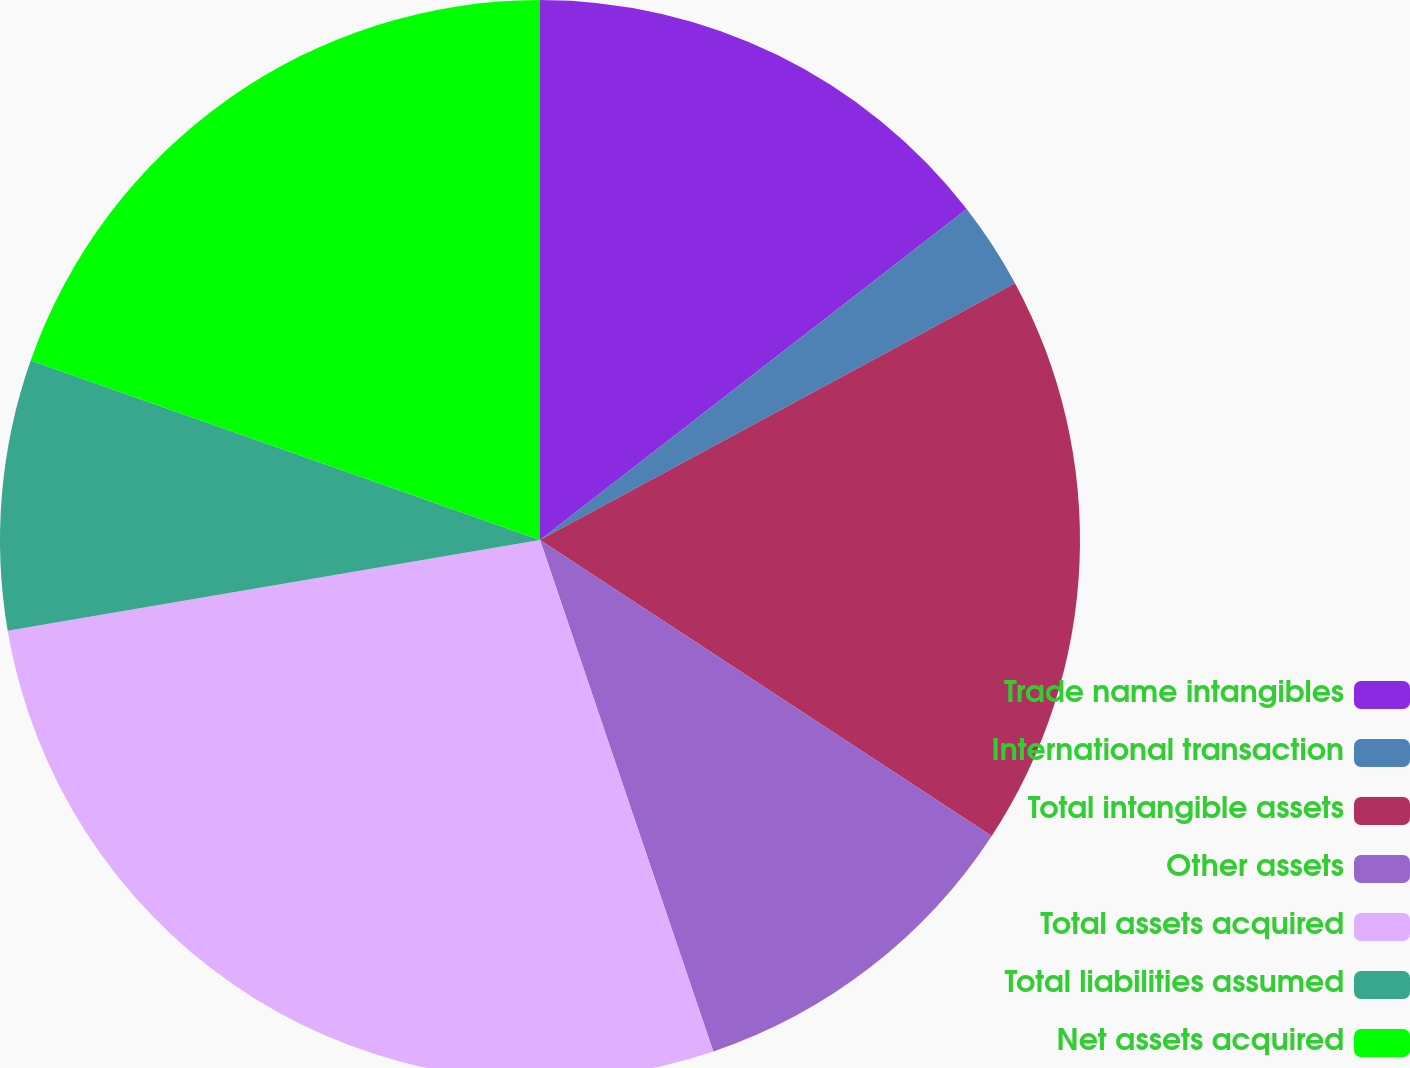Convert chart to OTSL. <chart><loc_0><loc_0><loc_500><loc_500><pie_chart><fcel>Trade name intangibles<fcel>International transaction<fcel>Total intangible assets<fcel>Other assets<fcel>Total assets acquired<fcel>Total liabilities assumed<fcel>Net assets acquired<nl><fcel>14.5%<fcel>2.61%<fcel>17.12%<fcel>10.57%<fcel>27.51%<fcel>8.08%<fcel>19.61%<nl></chart> 